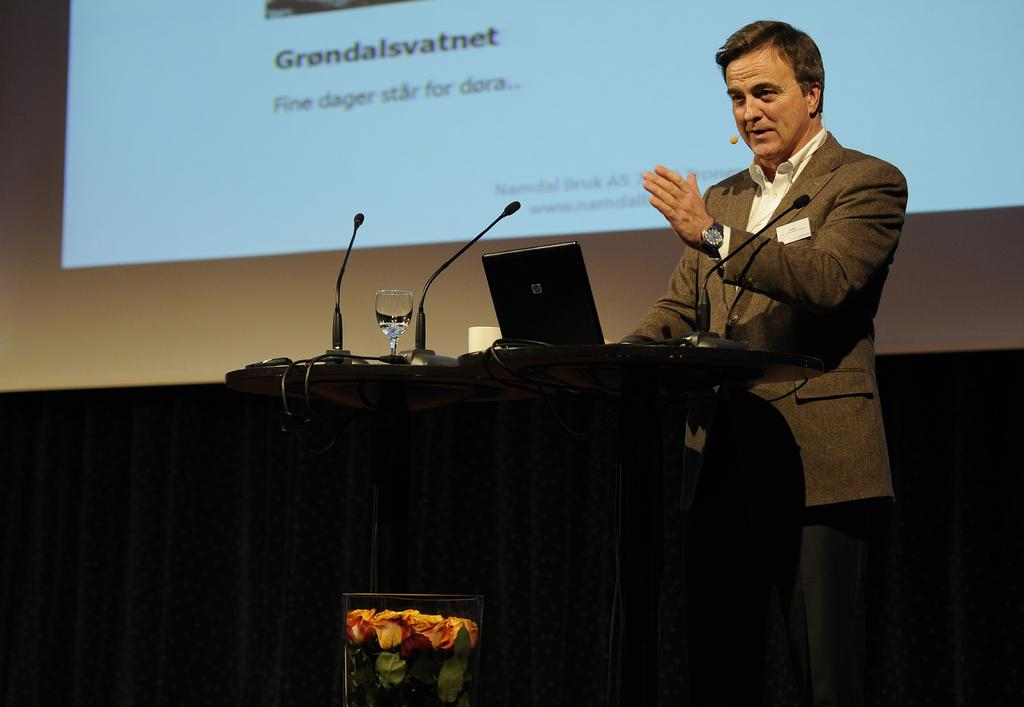What is the main subject of the image? There is a person standing in the image. What is the person wearing? The person is wearing a brown color blazer. What objects can be seen near the person? There are microphones visible in the image. What is on the podium in the image? There is a laptop on a podium in the image. What is in the background of the image? There is a projector screen in the background of the image. What type of scent can be smelled coming from the cakes in the image? There are no cakes present in the image, so it is not possible to determine any scent. 